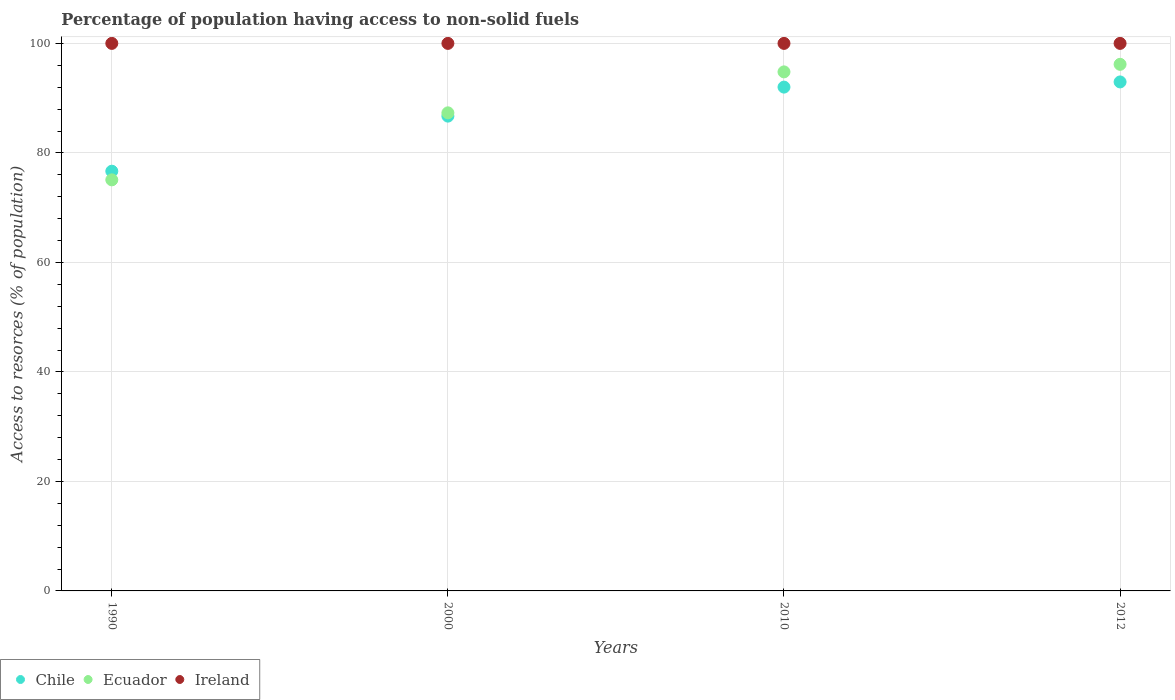Is the number of dotlines equal to the number of legend labels?
Keep it short and to the point. Yes. What is the percentage of population having access to non-solid fuels in Chile in 2010?
Provide a succinct answer. 92.02. Across all years, what is the maximum percentage of population having access to non-solid fuels in Ireland?
Provide a short and direct response. 100. Across all years, what is the minimum percentage of population having access to non-solid fuels in Chile?
Provide a short and direct response. 76.66. In which year was the percentage of population having access to non-solid fuels in Chile maximum?
Your response must be concise. 2012. What is the total percentage of population having access to non-solid fuels in Ireland in the graph?
Ensure brevity in your answer.  400. What is the difference between the percentage of population having access to non-solid fuels in Ecuador in 1990 and that in 2012?
Provide a succinct answer. -21.1. What is the difference between the percentage of population having access to non-solid fuels in Chile in 2010 and the percentage of population having access to non-solid fuels in Ireland in 2012?
Make the answer very short. -7.98. What is the average percentage of population having access to non-solid fuels in Chile per year?
Make the answer very short. 87.09. In the year 2010, what is the difference between the percentage of population having access to non-solid fuels in Ecuador and percentage of population having access to non-solid fuels in Ireland?
Make the answer very short. -5.2. In how many years, is the percentage of population having access to non-solid fuels in Chile greater than 72 %?
Keep it short and to the point. 4. Is the percentage of population having access to non-solid fuels in Ecuador in 1990 less than that in 2000?
Provide a short and direct response. Yes. What is the difference between the highest and the second highest percentage of population having access to non-solid fuels in Chile?
Your answer should be very brief. 0.94. What is the difference between the highest and the lowest percentage of population having access to non-solid fuels in Ecuador?
Provide a short and direct response. 21.1. In how many years, is the percentage of population having access to non-solid fuels in Ireland greater than the average percentage of population having access to non-solid fuels in Ireland taken over all years?
Ensure brevity in your answer.  0. Is the sum of the percentage of population having access to non-solid fuels in Ecuador in 2000 and 2010 greater than the maximum percentage of population having access to non-solid fuels in Ireland across all years?
Provide a short and direct response. Yes. Is it the case that in every year, the sum of the percentage of population having access to non-solid fuels in Ireland and percentage of population having access to non-solid fuels in Ecuador  is greater than the percentage of population having access to non-solid fuels in Chile?
Give a very brief answer. Yes. Is the percentage of population having access to non-solid fuels in Ireland strictly greater than the percentage of population having access to non-solid fuels in Ecuador over the years?
Give a very brief answer. Yes. Is the percentage of population having access to non-solid fuels in Chile strictly less than the percentage of population having access to non-solid fuels in Ecuador over the years?
Your answer should be very brief. No. How many dotlines are there?
Make the answer very short. 3. What is the difference between two consecutive major ticks on the Y-axis?
Your answer should be compact. 20. Are the values on the major ticks of Y-axis written in scientific E-notation?
Keep it short and to the point. No. Does the graph contain any zero values?
Ensure brevity in your answer.  No. Does the graph contain grids?
Give a very brief answer. Yes. Where does the legend appear in the graph?
Offer a terse response. Bottom left. How many legend labels are there?
Give a very brief answer. 3. How are the legend labels stacked?
Your answer should be compact. Horizontal. What is the title of the graph?
Provide a succinct answer. Percentage of population having access to non-solid fuels. What is the label or title of the Y-axis?
Provide a succinct answer. Access to resorces (% of population). What is the Access to resorces (% of population) in Chile in 1990?
Give a very brief answer. 76.66. What is the Access to resorces (% of population) in Ecuador in 1990?
Offer a very short reply. 75.08. What is the Access to resorces (% of population) in Ireland in 1990?
Your response must be concise. 100. What is the Access to resorces (% of population) in Chile in 2000?
Make the answer very short. 86.72. What is the Access to resorces (% of population) of Ecuador in 2000?
Provide a short and direct response. 87.32. What is the Access to resorces (% of population) in Ireland in 2000?
Offer a terse response. 100. What is the Access to resorces (% of population) in Chile in 2010?
Keep it short and to the point. 92.02. What is the Access to resorces (% of population) of Ecuador in 2010?
Your answer should be compact. 94.8. What is the Access to resorces (% of population) of Ireland in 2010?
Your answer should be compact. 100. What is the Access to resorces (% of population) in Chile in 2012?
Your answer should be compact. 92.96. What is the Access to resorces (% of population) in Ecuador in 2012?
Make the answer very short. 96.18. Across all years, what is the maximum Access to resorces (% of population) of Chile?
Offer a very short reply. 92.96. Across all years, what is the maximum Access to resorces (% of population) of Ecuador?
Offer a terse response. 96.18. Across all years, what is the minimum Access to resorces (% of population) in Chile?
Offer a very short reply. 76.66. Across all years, what is the minimum Access to resorces (% of population) of Ecuador?
Give a very brief answer. 75.08. What is the total Access to resorces (% of population) in Chile in the graph?
Make the answer very short. 348.35. What is the total Access to resorces (% of population) in Ecuador in the graph?
Keep it short and to the point. 353.37. What is the total Access to resorces (% of population) in Ireland in the graph?
Offer a very short reply. 400. What is the difference between the Access to resorces (% of population) of Chile in 1990 and that in 2000?
Provide a short and direct response. -10.06. What is the difference between the Access to resorces (% of population) of Ecuador in 1990 and that in 2000?
Offer a terse response. -12.24. What is the difference between the Access to resorces (% of population) in Ireland in 1990 and that in 2000?
Your answer should be very brief. 0. What is the difference between the Access to resorces (% of population) of Chile in 1990 and that in 2010?
Ensure brevity in your answer.  -15.36. What is the difference between the Access to resorces (% of population) of Ecuador in 1990 and that in 2010?
Provide a short and direct response. -19.72. What is the difference between the Access to resorces (% of population) in Chile in 1990 and that in 2012?
Offer a very short reply. -16.3. What is the difference between the Access to resorces (% of population) of Ecuador in 1990 and that in 2012?
Provide a succinct answer. -21.1. What is the difference between the Access to resorces (% of population) of Ireland in 1990 and that in 2012?
Make the answer very short. 0. What is the difference between the Access to resorces (% of population) of Chile in 2000 and that in 2010?
Offer a very short reply. -5.3. What is the difference between the Access to resorces (% of population) in Ecuador in 2000 and that in 2010?
Your response must be concise. -7.48. What is the difference between the Access to resorces (% of population) of Ireland in 2000 and that in 2010?
Offer a terse response. 0. What is the difference between the Access to resorces (% of population) in Chile in 2000 and that in 2012?
Offer a terse response. -6.24. What is the difference between the Access to resorces (% of population) of Ecuador in 2000 and that in 2012?
Offer a very short reply. -8.86. What is the difference between the Access to resorces (% of population) of Chile in 2010 and that in 2012?
Give a very brief answer. -0.94. What is the difference between the Access to resorces (% of population) in Ecuador in 2010 and that in 2012?
Ensure brevity in your answer.  -1.38. What is the difference between the Access to resorces (% of population) of Ireland in 2010 and that in 2012?
Make the answer very short. 0. What is the difference between the Access to resorces (% of population) of Chile in 1990 and the Access to resorces (% of population) of Ecuador in 2000?
Make the answer very short. -10.66. What is the difference between the Access to resorces (% of population) of Chile in 1990 and the Access to resorces (% of population) of Ireland in 2000?
Provide a succinct answer. -23.34. What is the difference between the Access to resorces (% of population) of Ecuador in 1990 and the Access to resorces (% of population) of Ireland in 2000?
Keep it short and to the point. -24.92. What is the difference between the Access to resorces (% of population) in Chile in 1990 and the Access to resorces (% of population) in Ecuador in 2010?
Keep it short and to the point. -18.14. What is the difference between the Access to resorces (% of population) in Chile in 1990 and the Access to resorces (% of population) in Ireland in 2010?
Keep it short and to the point. -23.34. What is the difference between the Access to resorces (% of population) of Ecuador in 1990 and the Access to resorces (% of population) of Ireland in 2010?
Provide a short and direct response. -24.92. What is the difference between the Access to resorces (% of population) of Chile in 1990 and the Access to resorces (% of population) of Ecuador in 2012?
Keep it short and to the point. -19.52. What is the difference between the Access to resorces (% of population) of Chile in 1990 and the Access to resorces (% of population) of Ireland in 2012?
Your answer should be very brief. -23.34. What is the difference between the Access to resorces (% of population) of Ecuador in 1990 and the Access to resorces (% of population) of Ireland in 2012?
Offer a terse response. -24.92. What is the difference between the Access to resorces (% of population) of Chile in 2000 and the Access to resorces (% of population) of Ecuador in 2010?
Offer a terse response. -8.08. What is the difference between the Access to resorces (% of population) in Chile in 2000 and the Access to resorces (% of population) in Ireland in 2010?
Provide a short and direct response. -13.28. What is the difference between the Access to resorces (% of population) of Ecuador in 2000 and the Access to resorces (% of population) of Ireland in 2010?
Ensure brevity in your answer.  -12.68. What is the difference between the Access to resorces (% of population) in Chile in 2000 and the Access to resorces (% of population) in Ecuador in 2012?
Give a very brief answer. -9.46. What is the difference between the Access to resorces (% of population) in Chile in 2000 and the Access to resorces (% of population) in Ireland in 2012?
Your response must be concise. -13.28. What is the difference between the Access to resorces (% of population) in Ecuador in 2000 and the Access to resorces (% of population) in Ireland in 2012?
Give a very brief answer. -12.68. What is the difference between the Access to resorces (% of population) of Chile in 2010 and the Access to resorces (% of population) of Ecuador in 2012?
Keep it short and to the point. -4.16. What is the difference between the Access to resorces (% of population) in Chile in 2010 and the Access to resorces (% of population) in Ireland in 2012?
Your response must be concise. -7.98. What is the difference between the Access to resorces (% of population) in Ecuador in 2010 and the Access to resorces (% of population) in Ireland in 2012?
Provide a succinct answer. -5.2. What is the average Access to resorces (% of population) of Chile per year?
Offer a terse response. 87.09. What is the average Access to resorces (% of population) of Ecuador per year?
Make the answer very short. 88.34. In the year 1990, what is the difference between the Access to resorces (% of population) in Chile and Access to resorces (% of population) in Ecuador?
Keep it short and to the point. 1.58. In the year 1990, what is the difference between the Access to resorces (% of population) of Chile and Access to resorces (% of population) of Ireland?
Give a very brief answer. -23.34. In the year 1990, what is the difference between the Access to resorces (% of population) of Ecuador and Access to resorces (% of population) of Ireland?
Your answer should be compact. -24.92. In the year 2000, what is the difference between the Access to resorces (% of population) of Chile and Access to resorces (% of population) of Ecuador?
Provide a succinct answer. -0.6. In the year 2000, what is the difference between the Access to resorces (% of population) in Chile and Access to resorces (% of population) in Ireland?
Your answer should be compact. -13.28. In the year 2000, what is the difference between the Access to resorces (% of population) of Ecuador and Access to resorces (% of population) of Ireland?
Provide a short and direct response. -12.68. In the year 2010, what is the difference between the Access to resorces (% of population) in Chile and Access to resorces (% of population) in Ecuador?
Your answer should be very brief. -2.78. In the year 2010, what is the difference between the Access to resorces (% of population) in Chile and Access to resorces (% of population) in Ireland?
Your answer should be compact. -7.98. In the year 2010, what is the difference between the Access to resorces (% of population) of Ecuador and Access to resorces (% of population) of Ireland?
Keep it short and to the point. -5.2. In the year 2012, what is the difference between the Access to resorces (% of population) in Chile and Access to resorces (% of population) in Ecuador?
Provide a short and direct response. -3.22. In the year 2012, what is the difference between the Access to resorces (% of population) in Chile and Access to resorces (% of population) in Ireland?
Offer a very short reply. -7.04. In the year 2012, what is the difference between the Access to resorces (% of population) in Ecuador and Access to resorces (% of population) in Ireland?
Your answer should be very brief. -3.82. What is the ratio of the Access to resorces (% of population) in Chile in 1990 to that in 2000?
Provide a succinct answer. 0.88. What is the ratio of the Access to resorces (% of population) in Ecuador in 1990 to that in 2000?
Your answer should be very brief. 0.86. What is the ratio of the Access to resorces (% of population) of Chile in 1990 to that in 2010?
Keep it short and to the point. 0.83. What is the ratio of the Access to resorces (% of population) in Ecuador in 1990 to that in 2010?
Keep it short and to the point. 0.79. What is the ratio of the Access to resorces (% of population) of Ireland in 1990 to that in 2010?
Your answer should be compact. 1. What is the ratio of the Access to resorces (% of population) of Chile in 1990 to that in 2012?
Ensure brevity in your answer.  0.82. What is the ratio of the Access to resorces (% of population) in Ecuador in 1990 to that in 2012?
Offer a terse response. 0.78. What is the ratio of the Access to resorces (% of population) in Ireland in 1990 to that in 2012?
Your answer should be very brief. 1. What is the ratio of the Access to resorces (% of population) in Chile in 2000 to that in 2010?
Your answer should be very brief. 0.94. What is the ratio of the Access to resorces (% of population) in Ecuador in 2000 to that in 2010?
Offer a very short reply. 0.92. What is the ratio of the Access to resorces (% of population) in Chile in 2000 to that in 2012?
Offer a very short reply. 0.93. What is the ratio of the Access to resorces (% of population) in Ecuador in 2000 to that in 2012?
Your response must be concise. 0.91. What is the ratio of the Access to resorces (% of population) of Ireland in 2000 to that in 2012?
Your answer should be very brief. 1. What is the ratio of the Access to resorces (% of population) of Ecuador in 2010 to that in 2012?
Provide a short and direct response. 0.99. What is the ratio of the Access to resorces (% of population) of Ireland in 2010 to that in 2012?
Offer a very short reply. 1. What is the difference between the highest and the second highest Access to resorces (% of population) in Chile?
Your response must be concise. 0.94. What is the difference between the highest and the second highest Access to resorces (% of population) of Ecuador?
Offer a very short reply. 1.38. What is the difference between the highest and the second highest Access to resorces (% of population) in Ireland?
Keep it short and to the point. 0. What is the difference between the highest and the lowest Access to resorces (% of population) of Chile?
Provide a short and direct response. 16.3. What is the difference between the highest and the lowest Access to resorces (% of population) of Ecuador?
Keep it short and to the point. 21.1. 